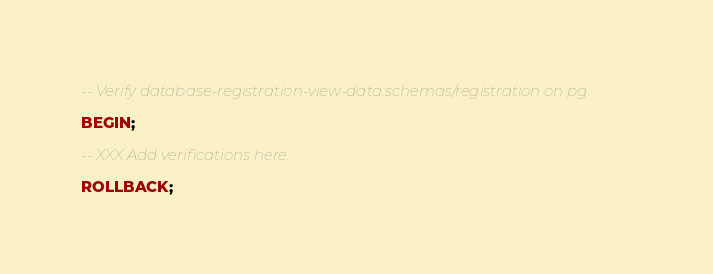<code> <loc_0><loc_0><loc_500><loc_500><_SQL_>-- Verify database-registration-view-data:schemas/registration on pg

BEGIN;

-- XXX Add verifications here.

ROLLBACK;
</code> 